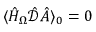Convert formula to latex. <formula><loc_0><loc_0><loc_500><loc_500>\langle \hat { H } _ { \Omega } \hat { \mathcal { D } } \hat { A } \rangle _ { 0 } = 0</formula> 